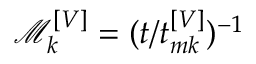Convert formula to latex. <formula><loc_0><loc_0><loc_500><loc_500>\mathcal { M } _ { k } ^ { \left [ V \right ] } = ( t / t _ { m k } ^ { \left [ V \right ] } ) ^ { - 1 }</formula> 